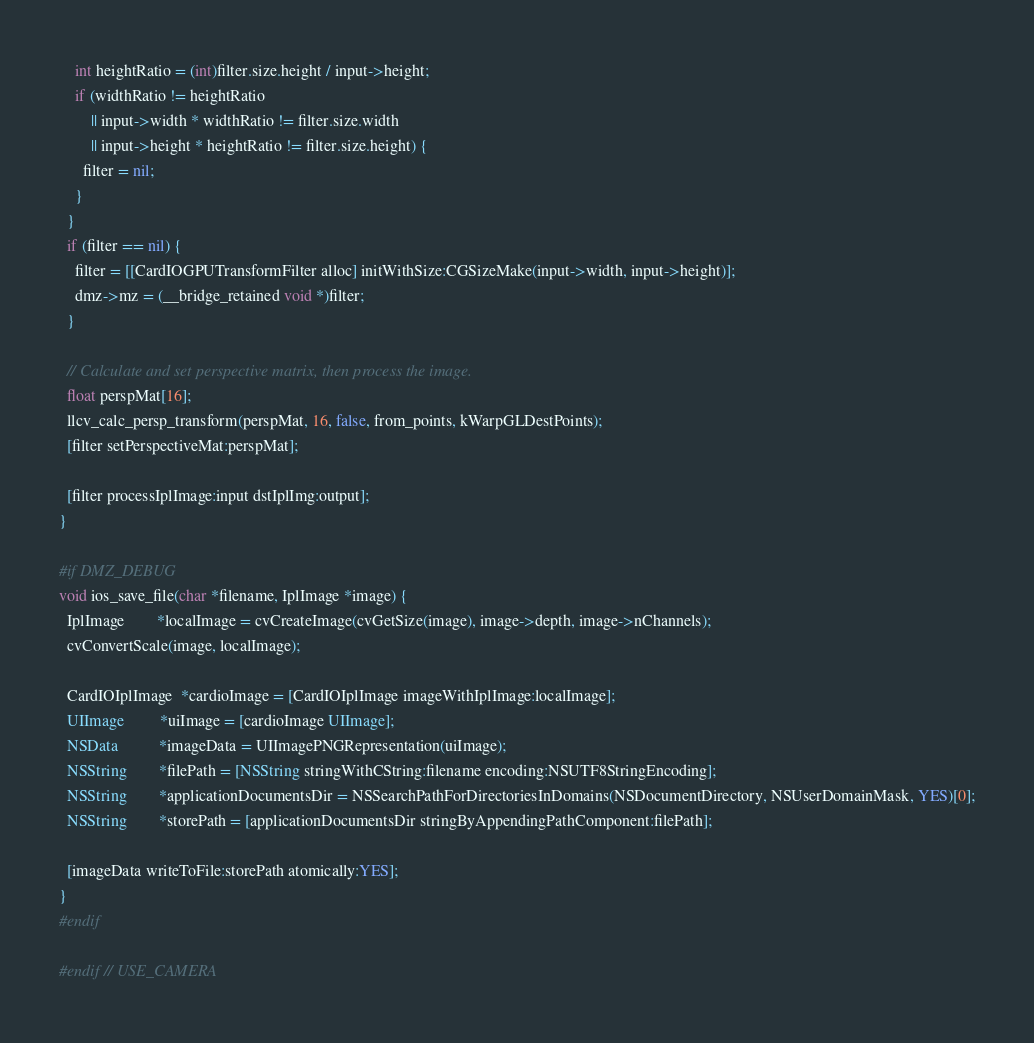<code> <loc_0><loc_0><loc_500><loc_500><_ObjectiveC_>    int heightRatio = (int)filter.size.height / input->height;
    if (widthRatio != heightRatio
        || input->width * widthRatio != filter.size.width
        || input->height * heightRatio != filter.size.height) {
      filter = nil;
    }
  }
  if (filter == nil) {
    filter = [[CardIOGPUTransformFilter alloc] initWithSize:CGSizeMake(input->width, input->height)];
    dmz->mz = (__bridge_retained void *)filter;
  }
  
  // Calculate and set perspective matrix, then process the image.
  float perspMat[16];
  llcv_calc_persp_transform(perspMat, 16, false, from_points, kWarpGLDestPoints);  
  [filter setPerspectiveMat:perspMat];

  [filter processIplImage:input dstIplImg:output];
}

#if DMZ_DEBUG
void ios_save_file(char *filename, IplImage *image) {
  IplImage        *localImage = cvCreateImage(cvGetSize(image), image->depth, image->nChannels);
  cvConvertScale(image, localImage);
  
  CardIOIplImage  *cardioImage = [CardIOIplImage imageWithIplImage:localImage];
  UIImage         *uiImage = [cardioImage UIImage];
  NSData          *imageData = UIImagePNGRepresentation(uiImage);
  NSString        *filePath = [NSString stringWithCString:filename encoding:NSUTF8StringEncoding];
  NSString        *applicationDocumentsDir = NSSearchPathForDirectoriesInDomains(NSDocumentDirectory, NSUserDomainMask, YES)[0];
  NSString        *storePath = [applicationDocumentsDir stringByAppendingPathComponent:filePath];
  
  [imageData writeToFile:storePath atomically:YES];
}
#endif

#endif // USE_CAMERA
</code> 